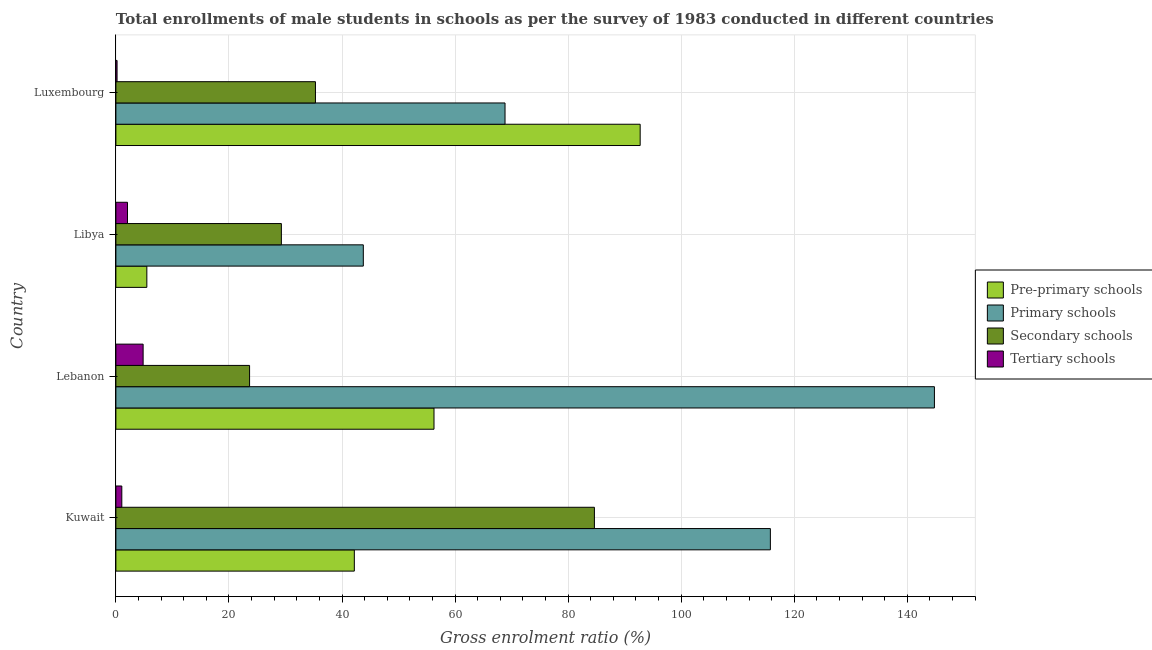How many different coloured bars are there?
Your answer should be compact. 4. How many bars are there on the 4th tick from the top?
Provide a short and direct response. 4. How many bars are there on the 3rd tick from the bottom?
Make the answer very short. 4. What is the label of the 3rd group of bars from the top?
Keep it short and to the point. Lebanon. What is the gross enrolment ratio(male) in tertiary schools in Luxembourg?
Provide a succinct answer. 0.21. Across all countries, what is the maximum gross enrolment ratio(male) in primary schools?
Offer a very short reply. 144.8. Across all countries, what is the minimum gross enrolment ratio(male) in tertiary schools?
Keep it short and to the point. 0.21. In which country was the gross enrolment ratio(male) in pre-primary schools maximum?
Ensure brevity in your answer.  Luxembourg. In which country was the gross enrolment ratio(male) in tertiary schools minimum?
Give a very brief answer. Luxembourg. What is the total gross enrolment ratio(male) in tertiary schools in the graph?
Make the answer very short. 8.13. What is the difference between the gross enrolment ratio(male) in secondary schools in Lebanon and that in Luxembourg?
Provide a short and direct response. -11.65. What is the difference between the gross enrolment ratio(male) in pre-primary schools in Libya and the gross enrolment ratio(male) in tertiary schools in Lebanon?
Offer a terse response. 0.66. What is the average gross enrolment ratio(male) in primary schools per country?
Offer a terse response. 93.3. What is the difference between the gross enrolment ratio(male) in secondary schools and gross enrolment ratio(male) in primary schools in Kuwait?
Keep it short and to the point. -31.13. In how many countries, is the gross enrolment ratio(male) in primary schools greater than 92 %?
Keep it short and to the point. 2. What is the ratio of the gross enrolment ratio(male) in secondary schools in Kuwait to that in Luxembourg?
Your answer should be very brief. 2.4. Is the difference between the gross enrolment ratio(male) in pre-primary schools in Kuwait and Lebanon greater than the difference between the gross enrolment ratio(male) in primary schools in Kuwait and Lebanon?
Provide a short and direct response. Yes. What is the difference between the highest and the second highest gross enrolment ratio(male) in primary schools?
Keep it short and to the point. 29.02. In how many countries, is the gross enrolment ratio(male) in pre-primary schools greater than the average gross enrolment ratio(male) in pre-primary schools taken over all countries?
Provide a succinct answer. 2. Is it the case that in every country, the sum of the gross enrolment ratio(male) in secondary schools and gross enrolment ratio(male) in pre-primary schools is greater than the sum of gross enrolment ratio(male) in tertiary schools and gross enrolment ratio(male) in primary schools?
Keep it short and to the point. No. What does the 1st bar from the top in Kuwait represents?
Your response must be concise. Tertiary schools. What does the 4th bar from the bottom in Kuwait represents?
Keep it short and to the point. Tertiary schools. How many bars are there?
Ensure brevity in your answer.  16. Are all the bars in the graph horizontal?
Ensure brevity in your answer.  Yes. Where does the legend appear in the graph?
Offer a very short reply. Center right. How are the legend labels stacked?
Ensure brevity in your answer.  Vertical. What is the title of the graph?
Give a very brief answer. Total enrollments of male students in schools as per the survey of 1983 conducted in different countries. What is the label or title of the X-axis?
Keep it short and to the point. Gross enrolment ratio (%). What is the label or title of the Y-axis?
Your response must be concise. Country. What is the Gross enrolment ratio (%) of Pre-primary schools in Kuwait?
Your response must be concise. 42.18. What is the Gross enrolment ratio (%) of Primary schools in Kuwait?
Give a very brief answer. 115.78. What is the Gross enrolment ratio (%) in Secondary schools in Kuwait?
Give a very brief answer. 84.65. What is the Gross enrolment ratio (%) of Tertiary schools in Kuwait?
Make the answer very short. 1.05. What is the Gross enrolment ratio (%) in Pre-primary schools in Lebanon?
Your answer should be very brief. 56.28. What is the Gross enrolment ratio (%) of Primary schools in Lebanon?
Provide a succinct answer. 144.8. What is the Gross enrolment ratio (%) of Secondary schools in Lebanon?
Offer a very short reply. 23.65. What is the Gross enrolment ratio (%) in Tertiary schools in Lebanon?
Give a very brief answer. 4.82. What is the Gross enrolment ratio (%) of Pre-primary schools in Libya?
Ensure brevity in your answer.  5.48. What is the Gross enrolment ratio (%) in Primary schools in Libya?
Make the answer very short. 43.77. What is the Gross enrolment ratio (%) of Secondary schools in Libya?
Your answer should be compact. 29.27. What is the Gross enrolment ratio (%) in Tertiary schools in Libya?
Provide a short and direct response. 2.05. What is the Gross enrolment ratio (%) of Pre-primary schools in Luxembourg?
Give a very brief answer. 92.75. What is the Gross enrolment ratio (%) of Primary schools in Luxembourg?
Keep it short and to the point. 68.84. What is the Gross enrolment ratio (%) in Secondary schools in Luxembourg?
Your answer should be very brief. 35.3. What is the Gross enrolment ratio (%) in Tertiary schools in Luxembourg?
Make the answer very short. 0.21. Across all countries, what is the maximum Gross enrolment ratio (%) in Pre-primary schools?
Your answer should be very brief. 92.75. Across all countries, what is the maximum Gross enrolment ratio (%) of Primary schools?
Your answer should be compact. 144.8. Across all countries, what is the maximum Gross enrolment ratio (%) in Secondary schools?
Offer a very short reply. 84.65. Across all countries, what is the maximum Gross enrolment ratio (%) of Tertiary schools?
Make the answer very short. 4.82. Across all countries, what is the minimum Gross enrolment ratio (%) in Pre-primary schools?
Give a very brief answer. 5.48. Across all countries, what is the minimum Gross enrolment ratio (%) in Primary schools?
Keep it short and to the point. 43.77. Across all countries, what is the minimum Gross enrolment ratio (%) in Secondary schools?
Ensure brevity in your answer.  23.65. Across all countries, what is the minimum Gross enrolment ratio (%) in Tertiary schools?
Your response must be concise. 0.21. What is the total Gross enrolment ratio (%) in Pre-primary schools in the graph?
Your answer should be compact. 196.68. What is the total Gross enrolment ratio (%) of Primary schools in the graph?
Ensure brevity in your answer.  373.19. What is the total Gross enrolment ratio (%) of Secondary schools in the graph?
Provide a short and direct response. 172.88. What is the total Gross enrolment ratio (%) of Tertiary schools in the graph?
Ensure brevity in your answer.  8.13. What is the difference between the Gross enrolment ratio (%) in Pre-primary schools in Kuwait and that in Lebanon?
Offer a very short reply. -14.1. What is the difference between the Gross enrolment ratio (%) of Primary schools in Kuwait and that in Lebanon?
Ensure brevity in your answer.  -29.02. What is the difference between the Gross enrolment ratio (%) of Secondary schools in Kuwait and that in Lebanon?
Offer a very short reply. 61. What is the difference between the Gross enrolment ratio (%) of Tertiary schools in Kuwait and that in Lebanon?
Provide a succinct answer. -3.77. What is the difference between the Gross enrolment ratio (%) of Pre-primary schools in Kuwait and that in Libya?
Your answer should be compact. 36.7. What is the difference between the Gross enrolment ratio (%) of Primary schools in Kuwait and that in Libya?
Provide a succinct answer. 72.01. What is the difference between the Gross enrolment ratio (%) in Secondary schools in Kuwait and that in Libya?
Your answer should be compact. 55.38. What is the difference between the Gross enrolment ratio (%) in Tertiary schools in Kuwait and that in Libya?
Offer a terse response. -1.01. What is the difference between the Gross enrolment ratio (%) of Pre-primary schools in Kuwait and that in Luxembourg?
Make the answer very short. -50.57. What is the difference between the Gross enrolment ratio (%) of Primary schools in Kuwait and that in Luxembourg?
Make the answer very short. 46.94. What is the difference between the Gross enrolment ratio (%) of Secondary schools in Kuwait and that in Luxembourg?
Give a very brief answer. 49.35. What is the difference between the Gross enrolment ratio (%) of Tertiary schools in Kuwait and that in Luxembourg?
Provide a succinct answer. 0.84. What is the difference between the Gross enrolment ratio (%) of Pre-primary schools in Lebanon and that in Libya?
Your answer should be very brief. 50.8. What is the difference between the Gross enrolment ratio (%) of Primary schools in Lebanon and that in Libya?
Offer a very short reply. 101.03. What is the difference between the Gross enrolment ratio (%) of Secondary schools in Lebanon and that in Libya?
Make the answer very short. -5.62. What is the difference between the Gross enrolment ratio (%) of Tertiary schools in Lebanon and that in Libya?
Ensure brevity in your answer.  2.77. What is the difference between the Gross enrolment ratio (%) of Pre-primary schools in Lebanon and that in Luxembourg?
Offer a very short reply. -36.47. What is the difference between the Gross enrolment ratio (%) of Primary schools in Lebanon and that in Luxembourg?
Make the answer very short. 75.96. What is the difference between the Gross enrolment ratio (%) of Secondary schools in Lebanon and that in Luxembourg?
Provide a short and direct response. -11.65. What is the difference between the Gross enrolment ratio (%) in Tertiary schools in Lebanon and that in Luxembourg?
Your answer should be compact. 4.61. What is the difference between the Gross enrolment ratio (%) in Pre-primary schools in Libya and that in Luxembourg?
Provide a succinct answer. -87.27. What is the difference between the Gross enrolment ratio (%) in Primary schools in Libya and that in Luxembourg?
Your answer should be compact. -25.07. What is the difference between the Gross enrolment ratio (%) in Secondary schools in Libya and that in Luxembourg?
Your answer should be compact. -6.03. What is the difference between the Gross enrolment ratio (%) of Tertiary schools in Libya and that in Luxembourg?
Provide a succinct answer. 1.85. What is the difference between the Gross enrolment ratio (%) in Pre-primary schools in Kuwait and the Gross enrolment ratio (%) in Primary schools in Lebanon?
Your response must be concise. -102.62. What is the difference between the Gross enrolment ratio (%) of Pre-primary schools in Kuwait and the Gross enrolment ratio (%) of Secondary schools in Lebanon?
Your answer should be very brief. 18.53. What is the difference between the Gross enrolment ratio (%) of Pre-primary schools in Kuwait and the Gross enrolment ratio (%) of Tertiary schools in Lebanon?
Provide a succinct answer. 37.36. What is the difference between the Gross enrolment ratio (%) of Primary schools in Kuwait and the Gross enrolment ratio (%) of Secondary schools in Lebanon?
Offer a terse response. 92.13. What is the difference between the Gross enrolment ratio (%) of Primary schools in Kuwait and the Gross enrolment ratio (%) of Tertiary schools in Lebanon?
Your response must be concise. 110.96. What is the difference between the Gross enrolment ratio (%) of Secondary schools in Kuwait and the Gross enrolment ratio (%) of Tertiary schools in Lebanon?
Provide a short and direct response. 79.83. What is the difference between the Gross enrolment ratio (%) in Pre-primary schools in Kuwait and the Gross enrolment ratio (%) in Primary schools in Libya?
Offer a very short reply. -1.59. What is the difference between the Gross enrolment ratio (%) of Pre-primary schools in Kuwait and the Gross enrolment ratio (%) of Secondary schools in Libya?
Keep it short and to the point. 12.91. What is the difference between the Gross enrolment ratio (%) in Pre-primary schools in Kuwait and the Gross enrolment ratio (%) in Tertiary schools in Libya?
Ensure brevity in your answer.  40.13. What is the difference between the Gross enrolment ratio (%) of Primary schools in Kuwait and the Gross enrolment ratio (%) of Secondary schools in Libya?
Your response must be concise. 86.51. What is the difference between the Gross enrolment ratio (%) in Primary schools in Kuwait and the Gross enrolment ratio (%) in Tertiary schools in Libya?
Give a very brief answer. 113.73. What is the difference between the Gross enrolment ratio (%) of Secondary schools in Kuwait and the Gross enrolment ratio (%) of Tertiary schools in Libya?
Provide a succinct answer. 82.6. What is the difference between the Gross enrolment ratio (%) in Pre-primary schools in Kuwait and the Gross enrolment ratio (%) in Primary schools in Luxembourg?
Make the answer very short. -26.66. What is the difference between the Gross enrolment ratio (%) in Pre-primary schools in Kuwait and the Gross enrolment ratio (%) in Secondary schools in Luxembourg?
Offer a terse response. 6.88. What is the difference between the Gross enrolment ratio (%) of Pre-primary schools in Kuwait and the Gross enrolment ratio (%) of Tertiary schools in Luxembourg?
Provide a short and direct response. 41.97. What is the difference between the Gross enrolment ratio (%) of Primary schools in Kuwait and the Gross enrolment ratio (%) of Secondary schools in Luxembourg?
Make the answer very short. 80.48. What is the difference between the Gross enrolment ratio (%) in Primary schools in Kuwait and the Gross enrolment ratio (%) in Tertiary schools in Luxembourg?
Provide a short and direct response. 115.57. What is the difference between the Gross enrolment ratio (%) of Secondary schools in Kuwait and the Gross enrolment ratio (%) of Tertiary schools in Luxembourg?
Offer a very short reply. 84.45. What is the difference between the Gross enrolment ratio (%) of Pre-primary schools in Lebanon and the Gross enrolment ratio (%) of Primary schools in Libya?
Keep it short and to the point. 12.5. What is the difference between the Gross enrolment ratio (%) of Pre-primary schools in Lebanon and the Gross enrolment ratio (%) of Secondary schools in Libya?
Your answer should be very brief. 27. What is the difference between the Gross enrolment ratio (%) in Pre-primary schools in Lebanon and the Gross enrolment ratio (%) in Tertiary schools in Libya?
Give a very brief answer. 54.22. What is the difference between the Gross enrolment ratio (%) in Primary schools in Lebanon and the Gross enrolment ratio (%) in Secondary schools in Libya?
Give a very brief answer. 115.53. What is the difference between the Gross enrolment ratio (%) in Primary schools in Lebanon and the Gross enrolment ratio (%) in Tertiary schools in Libya?
Ensure brevity in your answer.  142.75. What is the difference between the Gross enrolment ratio (%) in Secondary schools in Lebanon and the Gross enrolment ratio (%) in Tertiary schools in Libya?
Provide a succinct answer. 21.6. What is the difference between the Gross enrolment ratio (%) of Pre-primary schools in Lebanon and the Gross enrolment ratio (%) of Primary schools in Luxembourg?
Your answer should be very brief. -12.56. What is the difference between the Gross enrolment ratio (%) in Pre-primary schools in Lebanon and the Gross enrolment ratio (%) in Secondary schools in Luxembourg?
Give a very brief answer. 20.97. What is the difference between the Gross enrolment ratio (%) in Pre-primary schools in Lebanon and the Gross enrolment ratio (%) in Tertiary schools in Luxembourg?
Provide a succinct answer. 56.07. What is the difference between the Gross enrolment ratio (%) in Primary schools in Lebanon and the Gross enrolment ratio (%) in Secondary schools in Luxembourg?
Ensure brevity in your answer.  109.5. What is the difference between the Gross enrolment ratio (%) in Primary schools in Lebanon and the Gross enrolment ratio (%) in Tertiary schools in Luxembourg?
Offer a terse response. 144.6. What is the difference between the Gross enrolment ratio (%) of Secondary schools in Lebanon and the Gross enrolment ratio (%) of Tertiary schools in Luxembourg?
Ensure brevity in your answer.  23.44. What is the difference between the Gross enrolment ratio (%) of Pre-primary schools in Libya and the Gross enrolment ratio (%) of Primary schools in Luxembourg?
Your response must be concise. -63.36. What is the difference between the Gross enrolment ratio (%) of Pre-primary schools in Libya and the Gross enrolment ratio (%) of Secondary schools in Luxembourg?
Provide a succinct answer. -29.83. What is the difference between the Gross enrolment ratio (%) in Pre-primary schools in Libya and the Gross enrolment ratio (%) in Tertiary schools in Luxembourg?
Your answer should be compact. 5.27. What is the difference between the Gross enrolment ratio (%) of Primary schools in Libya and the Gross enrolment ratio (%) of Secondary schools in Luxembourg?
Your response must be concise. 8.47. What is the difference between the Gross enrolment ratio (%) of Primary schools in Libya and the Gross enrolment ratio (%) of Tertiary schools in Luxembourg?
Offer a very short reply. 43.56. What is the difference between the Gross enrolment ratio (%) in Secondary schools in Libya and the Gross enrolment ratio (%) in Tertiary schools in Luxembourg?
Keep it short and to the point. 29.07. What is the average Gross enrolment ratio (%) in Pre-primary schools per country?
Provide a short and direct response. 49.17. What is the average Gross enrolment ratio (%) of Primary schools per country?
Offer a terse response. 93.3. What is the average Gross enrolment ratio (%) in Secondary schools per country?
Provide a succinct answer. 43.22. What is the average Gross enrolment ratio (%) in Tertiary schools per country?
Give a very brief answer. 2.03. What is the difference between the Gross enrolment ratio (%) in Pre-primary schools and Gross enrolment ratio (%) in Primary schools in Kuwait?
Your answer should be compact. -73.6. What is the difference between the Gross enrolment ratio (%) of Pre-primary schools and Gross enrolment ratio (%) of Secondary schools in Kuwait?
Ensure brevity in your answer.  -42.47. What is the difference between the Gross enrolment ratio (%) of Pre-primary schools and Gross enrolment ratio (%) of Tertiary schools in Kuwait?
Ensure brevity in your answer.  41.13. What is the difference between the Gross enrolment ratio (%) in Primary schools and Gross enrolment ratio (%) in Secondary schools in Kuwait?
Your response must be concise. 31.13. What is the difference between the Gross enrolment ratio (%) in Primary schools and Gross enrolment ratio (%) in Tertiary schools in Kuwait?
Provide a succinct answer. 114.73. What is the difference between the Gross enrolment ratio (%) in Secondary schools and Gross enrolment ratio (%) in Tertiary schools in Kuwait?
Keep it short and to the point. 83.6. What is the difference between the Gross enrolment ratio (%) in Pre-primary schools and Gross enrolment ratio (%) in Primary schools in Lebanon?
Give a very brief answer. -88.53. What is the difference between the Gross enrolment ratio (%) in Pre-primary schools and Gross enrolment ratio (%) in Secondary schools in Lebanon?
Offer a terse response. 32.62. What is the difference between the Gross enrolment ratio (%) of Pre-primary schools and Gross enrolment ratio (%) of Tertiary schools in Lebanon?
Your response must be concise. 51.46. What is the difference between the Gross enrolment ratio (%) of Primary schools and Gross enrolment ratio (%) of Secondary schools in Lebanon?
Your answer should be compact. 121.15. What is the difference between the Gross enrolment ratio (%) of Primary schools and Gross enrolment ratio (%) of Tertiary schools in Lebanon?
Provide a succinct answer. 139.98. What is the difference between the Gross enrolment ratio (%) in Secondary schools and Gross enrolment ratio (%) in Tertiary schools in Lebanon?
Keep it short and to the point. 18.83. What is the difference between the Gross enrolment ratio (%) of Pre-primary schools and Gross enrolment ratio (%) of Primary schools in Libya?
Your answer should be compact. -38.29. What is the difference between the Gross enrolment ratio (%) of Pre-primary schools and Gross enrolment ratio (%) of Secondary schools in Libya?
Offer a terse response. -23.8. What is the difference between the Gross enrolment ratio (%) of Pre-primary schools and Gross enrolment ratio (%) of Tertiary schools in Libya?
Keep it short and to the point. 3.42. What is the difference between the Gross enrolment ratio (%) in Primary schools and Gross enrolment ratio (%) in Secondary schools in Libya?
Provide a succinct answer. 14.5. What is the difference between the Gross enrolment ratio (%) in Primary schools and Gross enrolment ratio (%) in Tertiary schools in Libya?
Offer a very short reply. 41.72. What is the difference between the Gross enrolment ratio (%) in Secondary schools and Gross enrolment ratio (%) in Tertiary schools in Libya?
Your response must be concise. 27.22. What is the difference between the Gross enrolment ratio (%) in Pre-primary schools and Gross enrolment ratio (%) in Primary schools in Luxembourg?
Provide a succinct answer. 23.91. What is the difference between the Gross enrolment ratio (%) in Pre-primary schools and Gross enrolment ratio (%) in Secondary schools in Luxembourg?
Ensure brevity in your answer.  57.44. What is the difference between the Gross enrolment ratio (%) of Pre-primary schools and Gross enrolment ratio (%) of Tertiary schools in Luxembourg?
Offer a very short reply. 92.54. What is the difference between the Gross enrolment ratio (%) in Primary schools and Gross enrolment ratio (%) in Secondary schools in Luxembourg?
Provide a short and direct response. 33.53. What is the difference between the Gross enrolment ratio (%) of Primary schools and Gross enrolment ratio (%) of Tertiary schools in Luxembourg?
Give a very brief answer. 68.63. What is the difference between the Gross enrolment ratio (%) of Secondary schools and Gross enrolment ratio (%) of Tertiary schools in Luxembourg?
Offer a terse response. 35.1. What is the ratio of the Gross enrolment ratio (%) in Pre-primary schools in Kuwait to that in Lebanon?
Offer a very short reply. 0.75. What is the ratio of the Gross enrolment ratio (%) of Primary schools in Kuwait to that in Lebanon?
Provide a succinct answer. 0.8. What is the ratio of the Gross enrolment ratio (%) of Secondary schools in Kuwait to that in Lebanon?
Make the answer very short. 3.58. What is the ratio of the Gross enrolment ratio (%) in Tertiary schools in Kuwait to that in Lebanon?
Provide a short and direct response. 0.22. What is the ratio of the Gross enrolment ratio (%) in Pre-primary schools in Kuwait to that in Libya?
Provide a short and direct response. 7.7. What is the ratio of the Gross enrolment ratio (%) in Primary schools in Kuwait to that in Libya?
Your answer should be compact. 2.65. What is the ratio of the Gross enrolment ratio (%) of Secondary schools in Kuwait to that in Libya?
Make the answer very short. 2.89. What is the ratio of the Gross enrolment ratio (%) in Tertiary schools in Kuwait to that in Libya?
Make the answer very short. 0.51. What is the ratio of the Gross enrolment ratio (%) in Pre-primary schools in Kuwait to that in Luxembourg?
Give a very brief answer. 0.45. What is the ratio of the Gross enrolment ratio (%) of Primary schools in Kuwait to that in Luxembourg?
Ensure brevity in your answer.  1.68. What is the ratio of the Gross enrolment ratio (%) of Secondary schools in Kuwait to that in Luxembourg?
Ensure brevity in your answer.  2.4. What is the ratio of the Gross enrolment ratio (%) of Tertiary schools in Kuwait to that in Luxembourg?
Your response must be concise. 5.07. What is the ratio of the Gross enrolment ratio (%) of Pre-primary schools in Lebanon to that in Libya?
Offer a terse response. 10.28. What is the ratio of the Gross enrolment ratio (%) of Primary schools in Lebanon to that in Libya?
Provide a succinct answer. 3.31. What is the ratio of the Gross enrolment ratio (%) of Secondary schools in Lebanon to that in Libya?
Offer a terse response. 0.81. What is the ratio of the Gross enrolment ratio (%) of Tertiary schools in Lebanon to that in Libya?
Your answer should be compact. 2.35. What is the ratio of the Gross enrolment ratio (%) of Pre-primary schools in Lebanon to that in Luxembourg?
Offer a terse response. 0.61. What is the ratio of the Gross enrolment ratio (%) of Primary schools in Lebanon to that in Luxembourg?
Keep it short and to the point. 2.1. What is the ratio of the Gross enrolment ratio (%) in Secondary schools in Lebanon to that in Luxembourg?
Offer a very short reply. 0.67. What is the ratio of the Gross enrolment ratio (%) in Tertiary schools in Lebanon to that in Luxembourg?
Your response must be concise. 23.29. What is the ratio of the Gross enrolment ratio (%) in Pre-primary schools in Libya to that in Luxembourg?
Give a very brief answer. 0.06. What is the ratio of the Gross enrolment ratio (%) in Primary schools in Libya to that in Luxembourg?
Your answer should be very brief. 0.64. What is the ratio of the Gross enrolment ratio (%) of Secondary schools in Libya to that in Luxembourg?
Provide a succinct answer. 0.83. What is the ratio of the Gross enrolment ratio (%) of Tertiary schools in Libya to that in Luxembourg?
Keep it short and to the point. 9.93. What is the difference between the highest and the second highest Gross enrolment ratio (%) in Pre-primary schools?
Your answer should be compact. 36.47. What is the difference between the highest and the second highest Gross enrolment ratio (%) in Primary schools?
Provide a short and direct response. 29.02. What is the difference between the highest and the second highest Gross enrolment ratio (%) of Secondary schools?
Keep it short and to the point. 49.35. What is the difference between the highest and the second highest Gross enrolment ratio (%) in Tertiary schools?
Your answer should be very brief. 2.77. What is the difference between the highest and the lowest Gross enrolment ratio (%) of Pre-primary schools?
Keep it short and to the point. 87.27. What is the difference between the highest and the lowest Gross enrolment ratio (%) of Primary schools?
Give a very brief answer. 101.03. What is the difference between the highest and the lowest Gross enrolment ratio (%) in Secondary schools?
Provide a short and direct response. 61. What is the difference between the highest and the lowest Gross enrolment ratio (%) of Tertiary schools?
Your response must be concise. 4.61. 